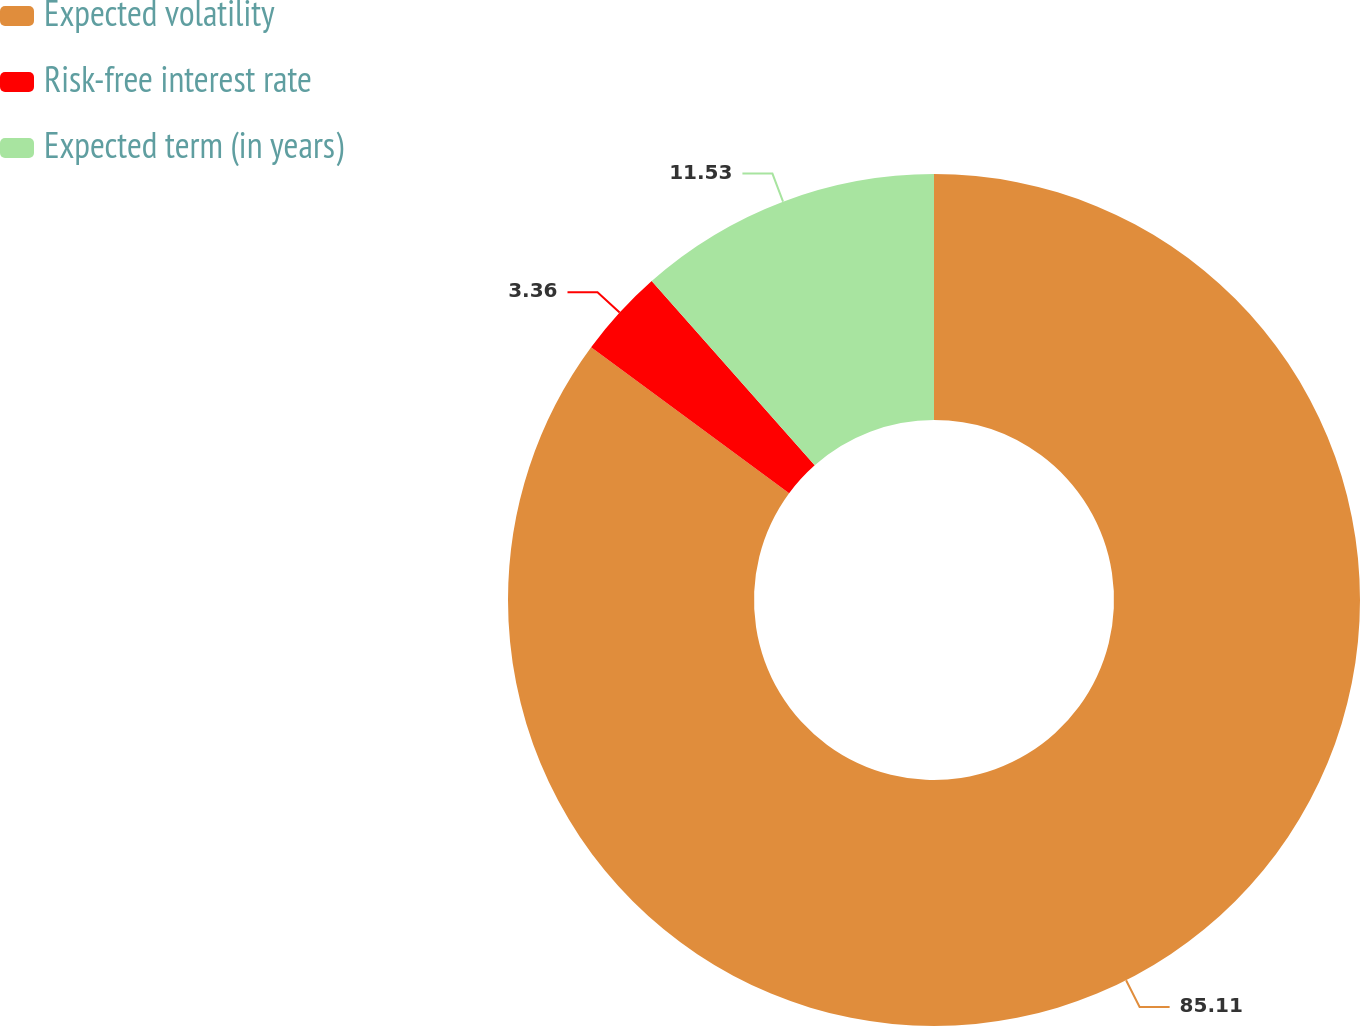<chart> <loc_0><loc_0><loc_500><loc_500><pie_chart><fcel>Expected volatility<fcel>Risk-free interest rate<fcel>Expected term (in years)<nl><fcel>85.11%<fcel>3.36%<fcel>11.53%<nl></chart> 